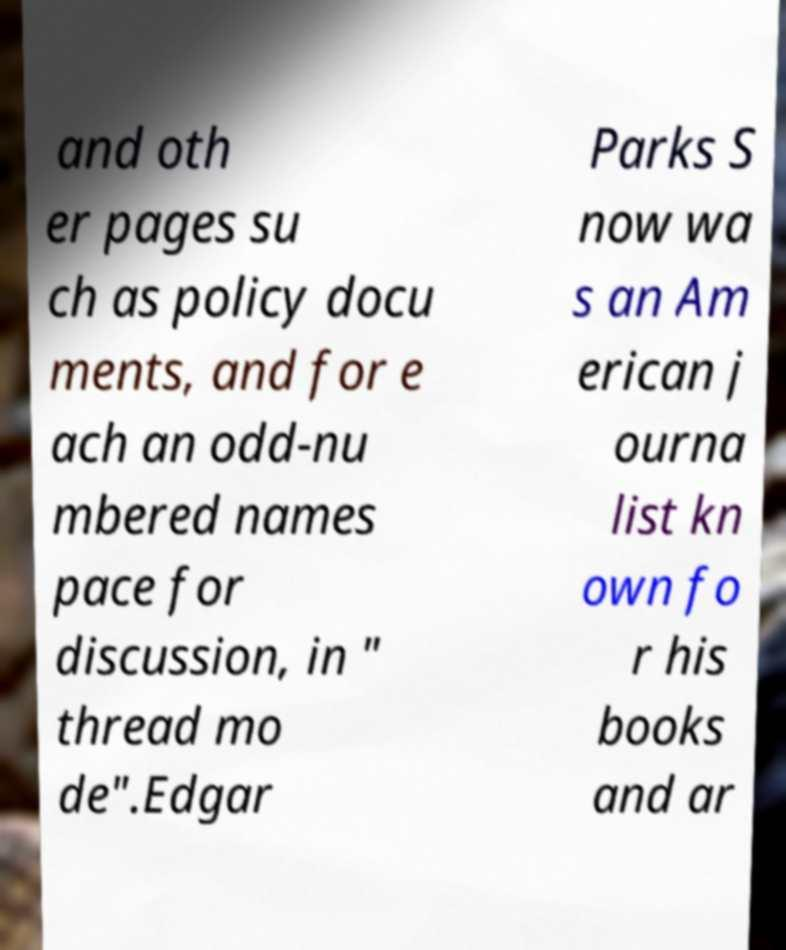Could you extract and type out the text from this image? and oth er pages su ch as policy docu ments, and for e ach an odd-nu mbered names pace for discussion, in " thread mo de".Edgar Parks S now wa s an Am erican j ourna list kn own fo r his books and ar 